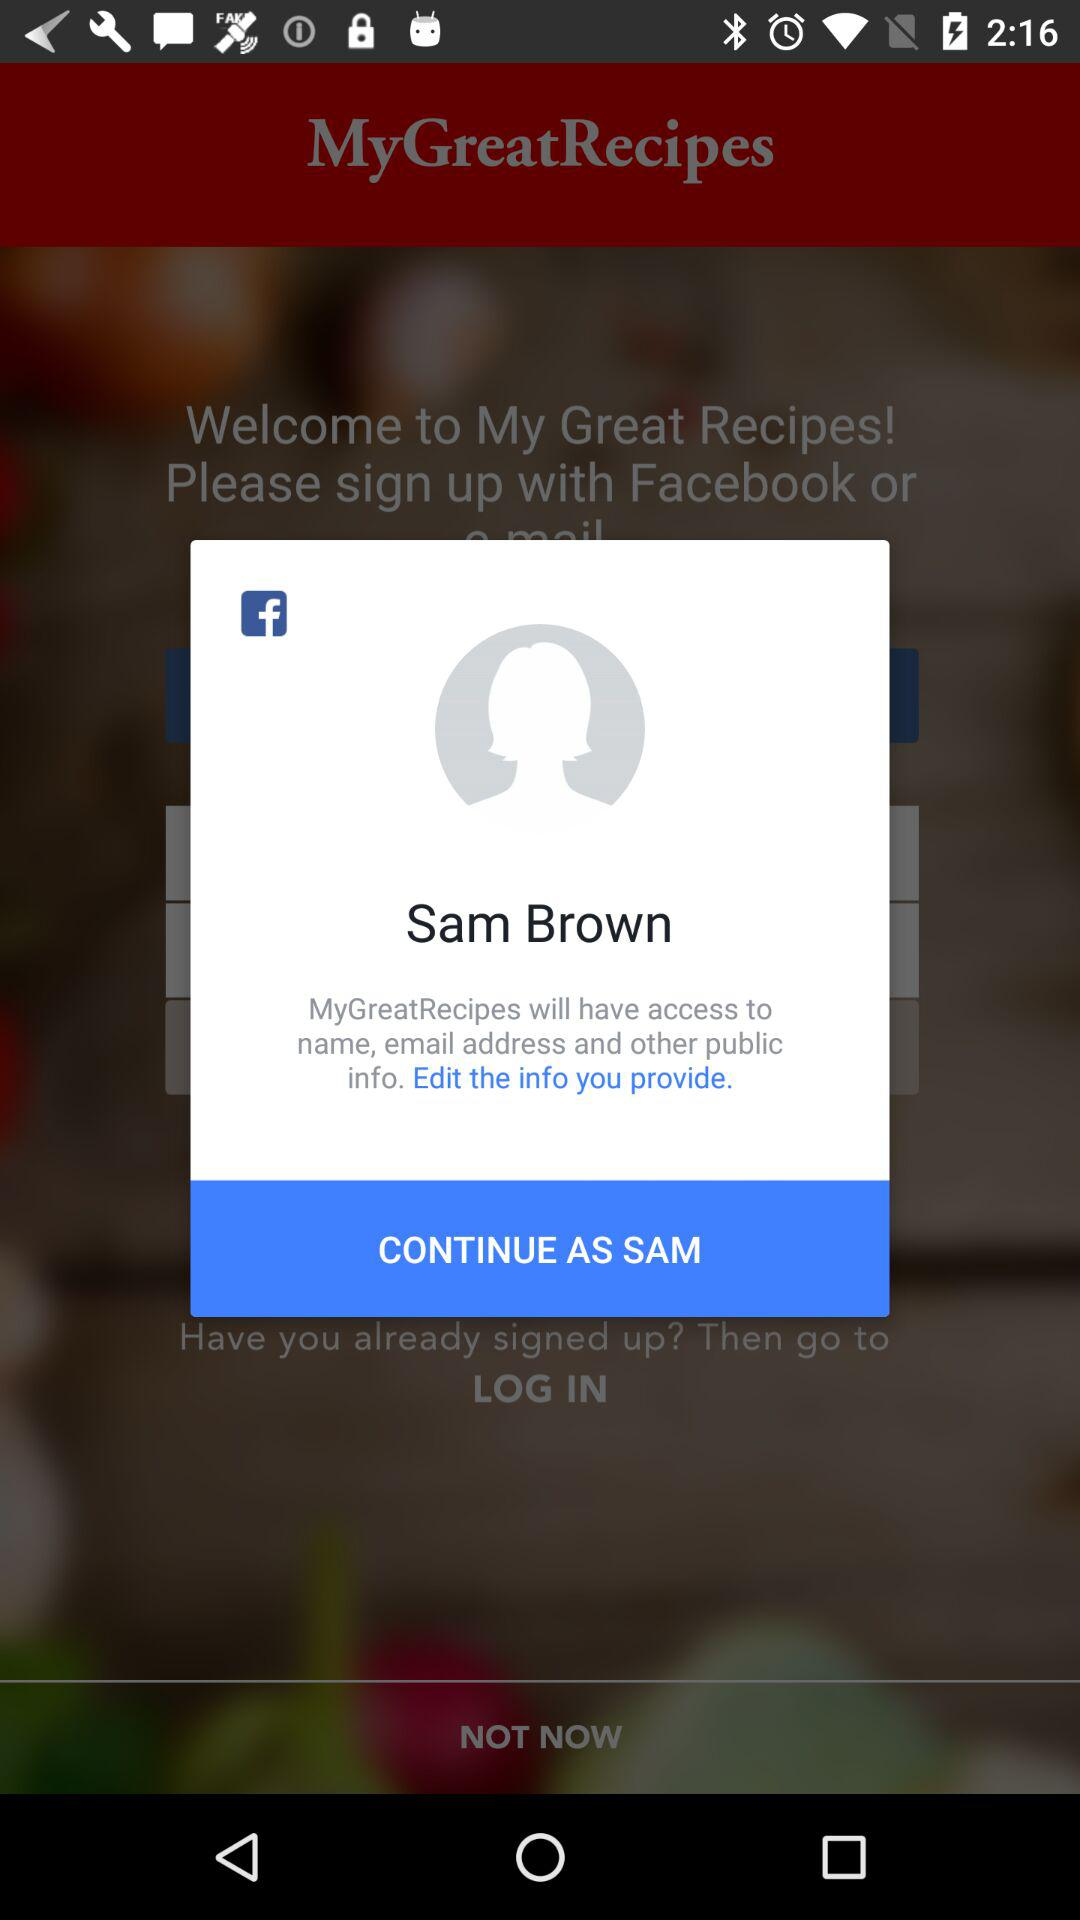What is the login name? The login name is Sam Brown. 